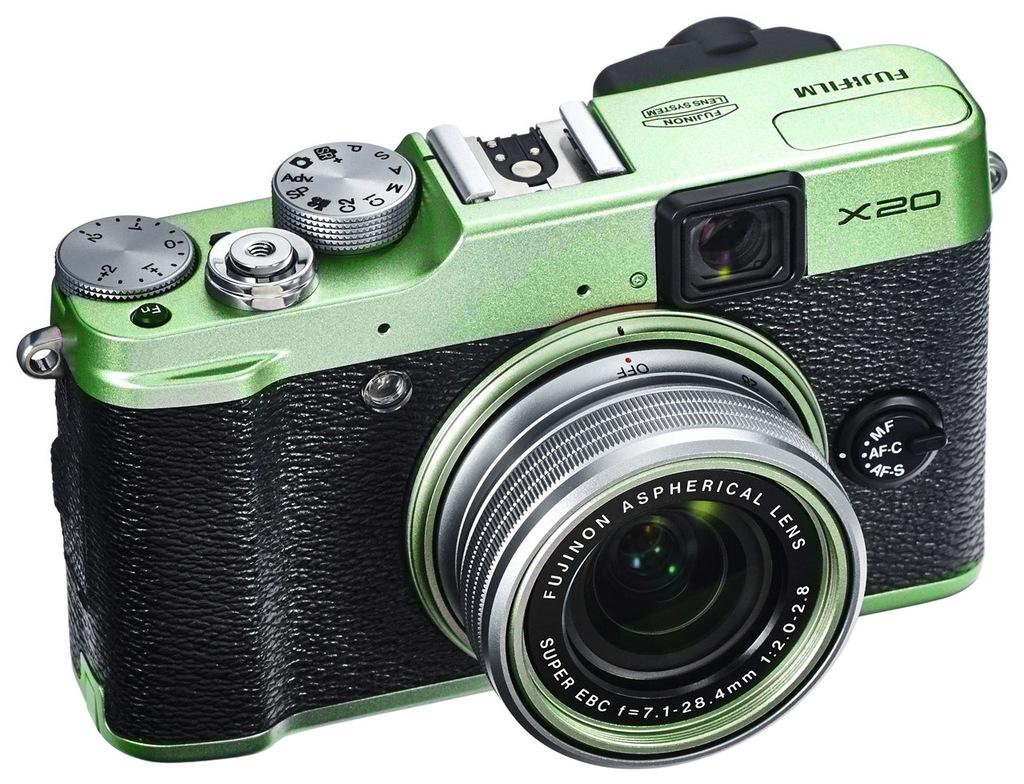What is the main object in the image? There is a camera in the image. Where is the camera placed? The camera is placed on a white platform. What rule is being enforced by the men in the image? There are no men present in the image, and therefore no rule enforcement can be observed. 